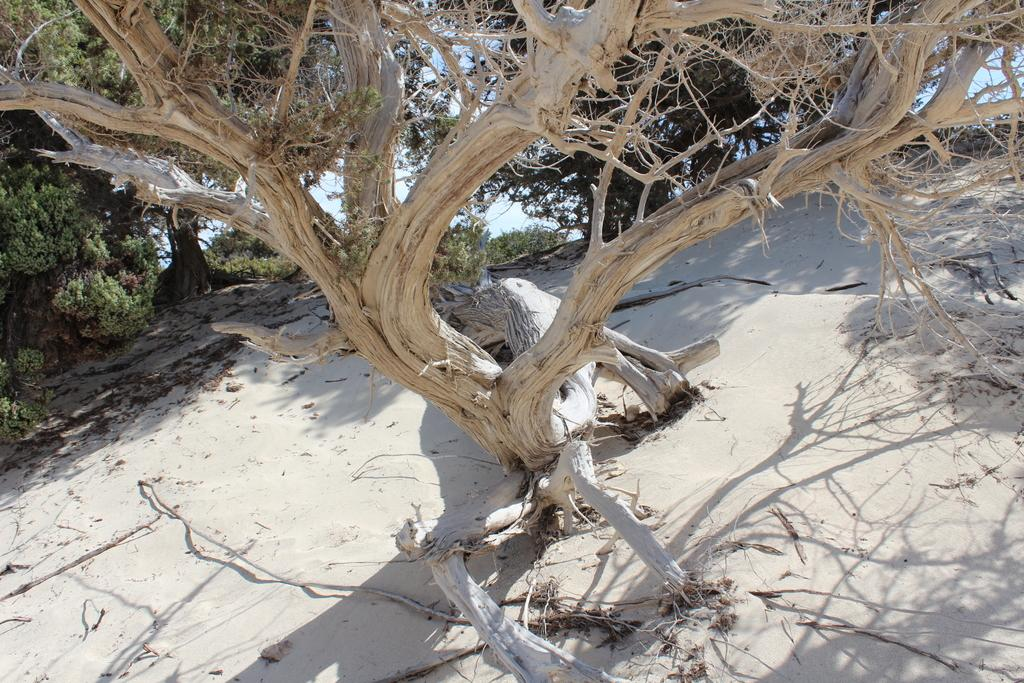What type of vegetation can be seen in the image? There are trees in the image. What is the terrain like where the trees are located? The trees are on a sandy land. What can be seen in the background of the image? The sky is visible in the background of the image. How many mists can be seen surrounding the trees in the image? There is no mist present in the image; it features trees on a sandy land with the sky visible in the background. 